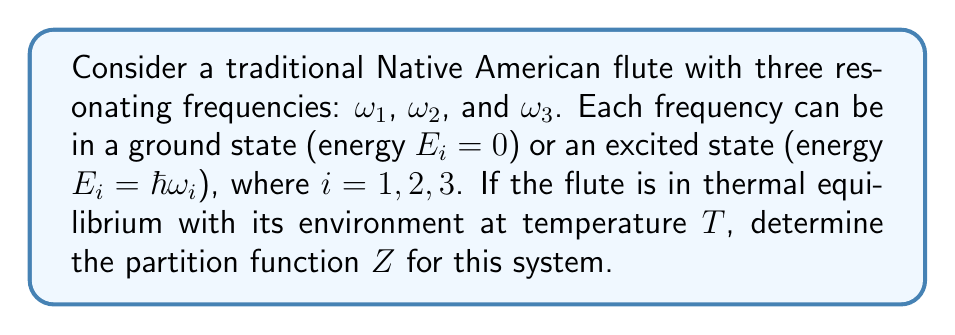Can you solve this math problem? To solve this problem, we'll follow these steps:

1) The partition function $Z$ is defined as the sum over all possible states of the system, each weighted by its Boltzmann factor:

   $$Z = \sum_i e^{-\beta E_i}$$

   where $\beta = \frac{1}{k_B T}$, $k_B$ is Boltzmann's constant, and $T$ is the temperature.

2) In this system, each frequency can be in one of two states (ground or excited). Therefore, we have $2^3 = 8$ possible states in total.

3) Let's enumerate these states and their energies:
   - State 1: All ground ($E = 0$)
   - State 2: $\omega_1$ excited ($E = \hbar\omega_1$)
   - State 3: $\omega_2$ excited ($E = \hbar\omega_2$)
   - State 4: $\omega_3$ excited ($E = \hbar\omega_3$)
   - State 5: $\omega_1$ and $\omega_2$ excited ($E = \hbar\omega_1 + \hbar\omega_2$)
   - State 6: $\omega_1$ and $\omega_3$ excited ($E = \hbar\omega_1 + \hbar\omega_3$)
   - State 7: $\omega_2$ and $\omega_3$ excited ($E = \hbar\omega_2 + \hbar\omega_3$)
   - State 8: All excited ($E = \hbar\omega_1 + \hbar\omega_2 + \hbar\omega_3$)

4) Now, let's write out the partition function:

   $$Z = e^{-\beta(0)} + e^{-\beta(\hbar\omega_1)} + e^{-\beta(\hbar\omega_2)} + e^{-\beta(\hbar\omega_3)} + e^{-\beta(\hbar\omega_1 + \hbar\omega_2)} + e^{-\beta(\hbar\omega_1 + \hbar\omega_3)} + e^{-\beta(\hbar\omega_2 + \hbar\omega_3)} + e^{-\beta(\hbar\omega_1 + \hbar\omega_2 + \hbar\omega_3)}$$

5) Simplify:

   $$Z = 1 + e^{-\beta\hbar\omega_1} + e^{-\beta\hbar\omega_2} + e^{-\beta\hbar\omega_3} + e^{-\beta\hbar(\omega_1 + \omega_2)} + e^{-\beta\hbar(\omega_1 + \omega_3)} + e^{-\beta\hbar(\omega_2 + \omega_3)} + e^{-\beta\hbar(\omega_1 + \omega_2 + \omega_3)}$$

6) This can be factored as:

   $$Z = (1 + e^{-\beta\hbar\omega_1})(1 + e^{-\beta\hbar\omega_2})(1 + e^{-\beta\hbar\omega_3})$$

This is the final form of the partition function for this system.
Answer: $Z = (1 + e^{-\beta\hbar\omega_1})(1 + e^{-\beta\hbar\omega_2})(1 + e^{-\beta\hbar\omega_3})$ 